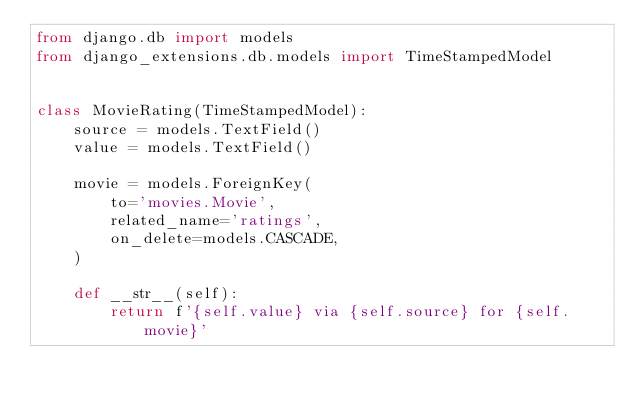Convert code to text. <code><loc_0><loc_0><loc_500><loc_500><_Python_>from django.db import models
from django_extensions.db.models import TimeStampedModel


class MovieRating(TimeStampedModel):
    source = models.TextField()
    value = models.TextField()

    movie = models.ForeignKey(
        to='movies.Movie',
        related_name='ratings',
        on_delete=models.CASCADE,
    )

    def __str__(self):
        return f'{self.value} via {self.source} for {self.movie}'
</code> 